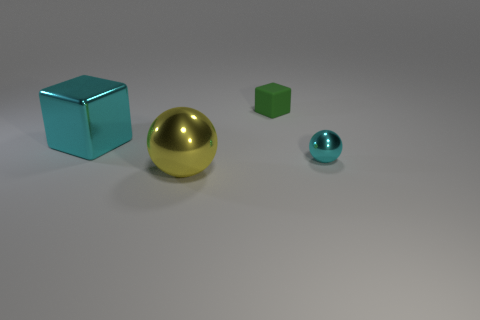Subtract all green blocks. How many blocks are left? 1 Add 4 large shiny cubes. How many objects exist? 8 Subtract all brown shiny blocks. Subtract all cyan metallic spheres. How many objects are left? 3 Add 2 yellow spheres. How many yellow spheres are left? 3 Add 2 large metallic balls. How many large metallic balls exist? 3 Subtract 0 red cubes. How many objects are left? 4 